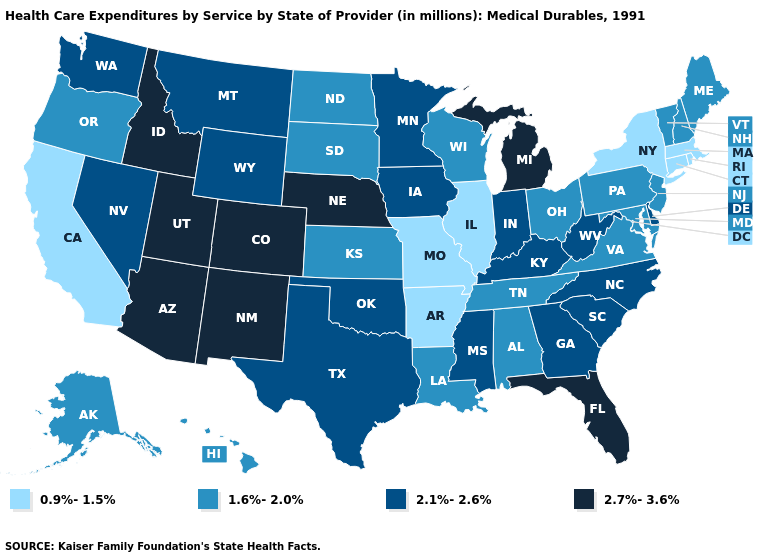What is the lowest value in states that border Nevada?
Be succinct. 0.9%-1.5%. Name the states that have a value in the range 0.9%-1.5%?
Answer briefly. Arkansas, California, Connecticut, Illinois, Massachusetts, Missouri, New York, Rhode Island. Does Maryland have a higher value than Connecticut?
Write a very short answer. Yes. What is the lowest value in the MidWest?
Be succinct. 0.9%-1.5%. Does Connecticut have a lower value than Kansas?
Be succinct. Yes. What is the value of Iowa?
Answer briefly. 2.1%-2.6%. Name the states that have a value in the range 0.9%-1.5%?
Answer briefly. Arkansas, California, Connecticut, Illinois, Massachusetts, Missouri, New York, Rhode Island. Does the map have missing data?
Write a very short answer. No. What is the value of New Jersey?
Concise answer only. 1.6%-2.0%. What is the value of Virginia?
Answer briefly. 1.6%-2.0%. Does Alaska have the highest value in the West?
Concise answer only. No. Does Rhode Island have the lowest value in the Northeast?
Give a very brief answer. Yes. What is the value of Minnesota?
Quick response, please. 2.1%-2.6%. Name the states that have a value in the range 2.7%-3.6%?
Short answer required. Arizona, Colorado, Florida, Idaho, Michigan, Nebraska, New Mexico, Utah. What is the highest value in the USA?
Be succinct. 2.7%-3.6%. 